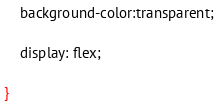<code> <loc_0><loc_0><loc_500><loc_500><_CSS_>	background-color:transparent;
	
	display: flex;
	
}</code> 